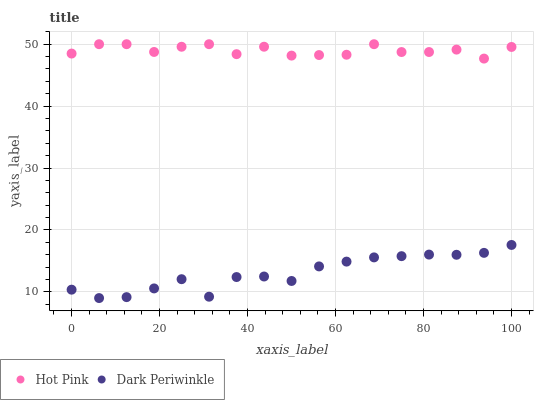Does Dark Periwinkle have the minimum area under the curve?
Answer yes or no. Yes. Does Hot Pink have the maximum area under the curve?
Answer yes or no. Yes. Does Dark Periwinkle have the maximum area under the curve?
Answer yes or no. No. Is Dark Periwinkle the smoothest?
Answer yes or no. Yes. Is Hot Pink the roughest?
Answer yes or no. Yes. Is Dark Periwinkle the roughest?
Answer yes or no. No. Does Dark Periwinkle have the lowest value?
Answer yes or no. Yes. Does Hot Pink have the highest value?
Answer yes or no. Yes. Does Dark Periwinkle have the highest value?
Answer yes or no. No. Is Dark Periwinkle less than Hot Pink?
Answer yes or no. Yes. Is Hot Pink greater than Dark Periwinkle?
Answer yes or no. Yes. Does Dark Periwinkle intersect Hot Pink?
Answer yes or no. No. 